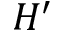<formula> <loc_0><loc_0><loc_500><loc_500>H ^ { \prime }</formula> 